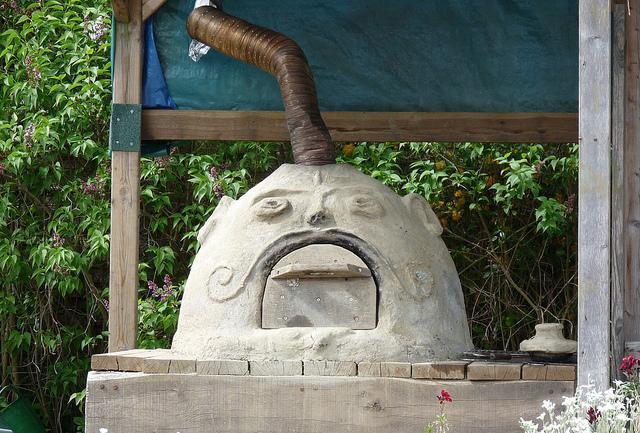How many adult giraffes are in the image?
Give a very brief answer. 0. 